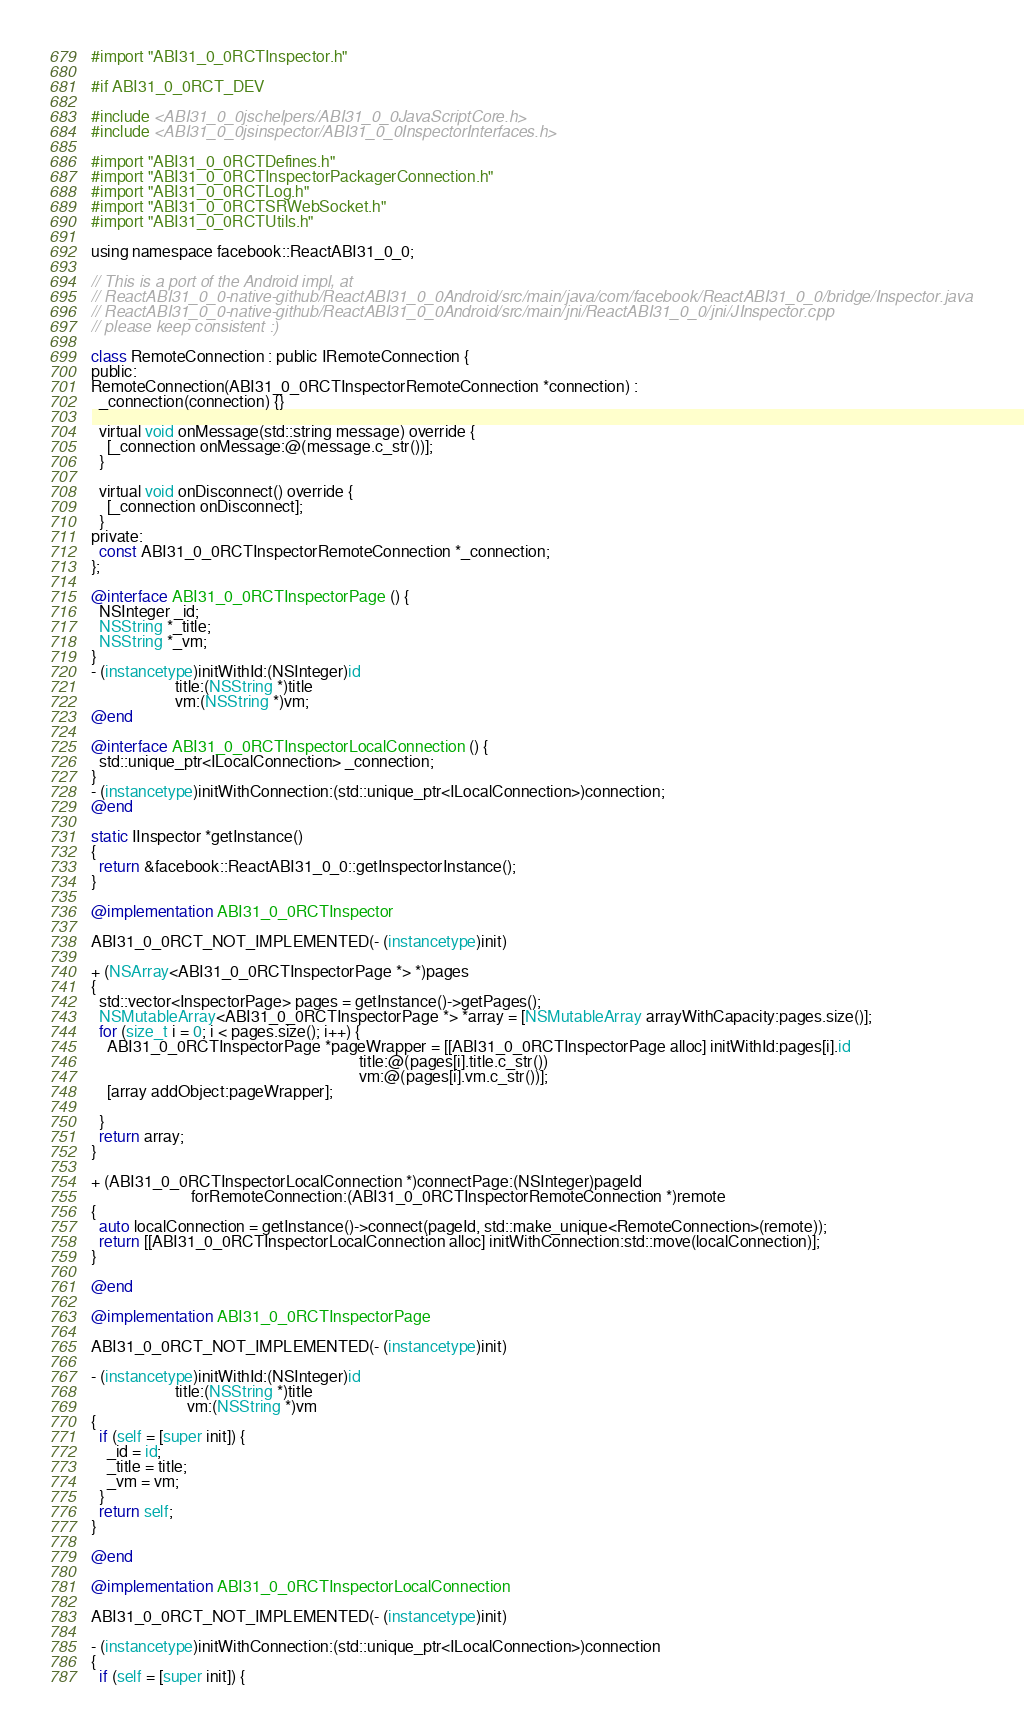Convert code to text. <code><loc_0><loc_0><loc_500><loc_500><_ObjectiveC_>
#import "ABI31_0_0RCTInspector.h"

#if ABI31_0_0RCT_DEV

#include <ABI31_0_0jschelpers/ABI31_0_0JavaScriptCore.h>
#include <ABI31_0_0jsinspector/ABI31_0_0InspectorInterfaces.h>

#import "ABI31_0_0RCTDefines.h"
#import "ABI31_0_0RCTInspectorPackagerConnection.h"
#import "ABI31_0_0RCTLog.h"
#import "ABI31_0_0RCTSRWebSocket.h"
#import "ABI31_0_0RCTUtils.h"

using namespace facebook::ReactABI31_0_0;

// This is a port of the Android impl, at
// ReactABI31_0_0-native-github/ReactABI31_0_0Android/src/main/java/com/facebook/ReactABI31_0_0/bridge/Inspector.java
// ReactABI31_0_0-native-github/ReactABI31_0_0Android/src/main/jni/ReactABI31_0_0/jni/JInspector.cpp
// please keep consistent :)

class RemoteConnection : public IRemoteConnection {
public:
RemoteConnection(ABI31_0_0RCTInspectorRemoteConnection *connection) :
  _connection(connection) {}

  virtual void onMessage(std::string message) override {
    [_connection onMessage:@(message.c_str())];
  }

  virtual void onDisconnect() override {
    [_connection onDisconnect];
  }
private:
  const ABI31_0_0RCTInspectorRemoteConnection *_connection;
};

@interface ABI31_0_0RCTInspectorPage () {
  NSInteger _id;
  NSString *_title;
  NSString *_vm;
}
- (instancetype)initWithId:(NSInteger)id
                     title:(NSString *)title
                     vm:(NSString *)vm;
@end

@interface ABI31_0_0RCTInspectorLocalConnection () {
  std::unique_ptr<ILocalConnection> _connection;
}
- (instancetype)initWithConnection:(std::unique_ptr<ILocalConnection>)connection;
@end

static IInspector *getInstance()
{
  return &facebook::ReactABI31_0_0::getInspectorInstance();
}

@implementation ABI31_0_0RCTInspector

ABI31_0_0RCT_NOT_IMPLEMENTED(- (instancetype)init)

+ (NSArray<ABI31_0_0RCTInspectorPage *> *)pages
{
  std::vector<InspectorPage> pages = getInstance()->getPages();
  NSMutableArray<ABI31_0_0RCTInspectorPage *> *array = [NSMutableArray arrayWithCapacity:pages.size()];
  for (size_t i = 0; i < pages.size(); i++) {
    ABI31_0_0RCTInspectorPage *pageWrapper = [[ABI31_0_0RCTInspectorPage alloc] initWithId:pages[i].id
                                                                   title:@(pages[i].title.c_str())
                                                                   vm:@(pages[i].vm.c_str())];
    [array addObject:pageWrapper];

  }
  return array;
}

+ (ABI31_0_0RCTInspectorLocalConnection *)connectPage:(NSInteger)pageId
                         forRemoteConnection:(ABI31_0_0RCTInspectorRemoteConnection *)remote
{
  auto localConnection = getInstance()->connect(pageId, std::make_unique<RemoteConnection>(remote));
  return [[ABI31_0_0RCTInspectorLocalConnection alloc] initWithConnection:std::move(localConnection)];
}

@end

@implementation ABI31_0_0RCTInspectorPage

ABI31_0_0RCT_NOT_IMPLEMENTED(- (instancetype)init)

- (instancetype)initWithId:(NSInteger)id
                     title:(NSString *)title
                        vm:(NSString *)vm
{
  if (self = [super init]) {
    _id = id;
    _title = title;
    _vm = vm;
  }
  return self;
}

@end

@implementation ABI31_0_0RCTInspectorLocalConnection

ABI31_0_0RCT_NOT_IMPLEMENTED(- (instancetype)init)

- (instancetype)initWithConnection:(std::unique_ptr<ILocalConnection>)connection
{
  if (self = [super init]) {</code> 